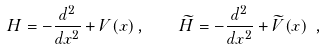Convert formula to latex. <formula><loc_0><loc_0><loc_500><loc_500>H = - \frac { d ^ { 2 } } { d x ^ { 2 } } + V ( x ) \, , \quad \widetilde { H } = - \frac { d ^ { 2 } } { d x ^ { 2 } } + \widetilde { V } ( x ) \ ,</formula> 